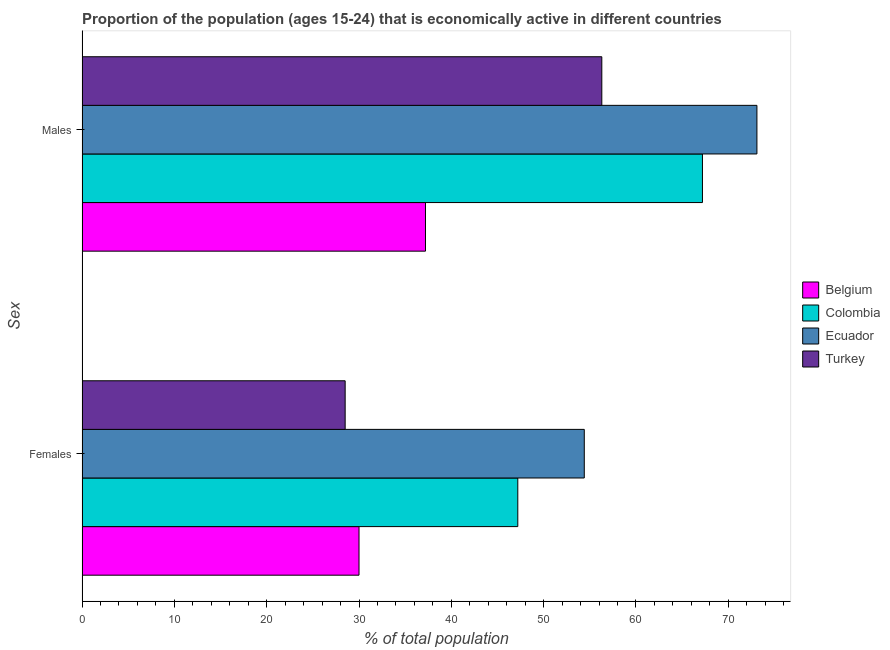How many different coloured bars are there?
Offer a very short reply. 4. How many groups of bars are there?
Provide a short and direct response. 2. Are the number of bars per tick equal to the number of legend labels?
Provide a succinct answer. Yes. Are the number of bars on each tick of the Y-axis equal?
Ensure brevity in your answer.  Yes. What is the label of the 1st group of bars from the top?
Give a very brief answer. Males. What is the percentage of economically active female population in Ecuador?
Your response must be concise. 54.4. Across all countries, what is the maximum percentage of economically active male population?
Your answer should be very brief. 73.1. Across all countries, what is the minimum percentage of economically active male population?
Ensure brevity in your answer.  37.2. In which country was the percentage of economically active male population maximum?
Your response must be concise. Ecuador. In which country was the percentage of economically active female population minimum?
Provide a succinct answer. Turkey. What is the total percentage of economically active female population in the graph?
Your answer should be very brief. 160.1. What is the difference between the percentage of economically active female population in Ecuador and that in Belgium?
Your answer should be very brief. 24.4. What is the difference between the percentage of economically active female population in Belgium and the percentage of economically active male population in Turkey?
Ensure brevity in your answer.  -26.3. What is the average percentage of economically active male population per country?
Ensure brevity in your answer.  58.45. What is the difference between the percentage of economically active female population and percentage of economically active male population in Colombia?
Provide a succinct answer. -20. What is the ratio of the percentage of economically active female population in Colombia to that in Belgium?
Make the answer very short. 1.57. In how many countries, is the percentage of economically active female population greater than the average percentage of economically active female population taken over all countries?
Provide a short and direct response. 2. What does the 2nd bar from the top in Females represents?
Offer a very short reply. Ecuador. Are all the bars in the graph horizontal?
Your answer should be very brief. Yes. Are the values on the major ticks of X-axis written in scientific E-notation?
Ensure brevity in your answer.  No. Does the graph contain any zero values?
Your response must be concise. No. How many legend labels are there?
Make the answer very short. 4. How are the legend labels stacked?
Provide a succinct answer. Vertical. What is the title of the graph?
Give a very brief answer. Proportion of the population (ages 15-24) that is economically active in different countries. What is the label or title of the X-axis?
Your answer should be compact. % of total population. What is the label or title of the Y-axis?
Keep it short and to the point. Sex. What is the % of total population in Belgium in Females?
Your answer should be very brief. 30. What is the % of total population of Colombia in Females?
Your answer should be very brief. 47.2. What is the % of total population of Ecuador in Females?
Your answer should be very brief. 54.4. What is the % of total population in Turkey in Females?
Your response must be concise. 28.5. What is the % of total population in Belgium in Males?
Offer a terse response. 37.2. What is the % of total population of Colombia in Males?
Give a very brief answer. 67.2. What is the % of total population of Ecuador in Males?
Your answer should be very brief. 73.1. What is the % of total population of Turkey in Males?
Provide a short and direct response. 56.3. Across all Sex, what is the maximum % of total population in Belgium?
Your answer should be very brief. 37.2. Across all Sex, what is the maximum % of total population of Colombia?
Your answer should be compact. 67.2. Across all Sex, what is the maximum % of total population of Ecuador?
Provide a short and direct response. 73.1. Across all Sex, what is the maximum % of total population of Turkey?
Offer a very short reply. 56.3. Across all Sex, what is the minimum % of total population in Colombia?
Give a very brief answer. 47.2. Across all Sex, what is the minimum % of total population of Ecuador?
Your answer should be compact. 54.4. What is the total % of total population of Belgium in the graph?
Offer a very short reply. 67.2. What is the total % of total population in Colombia in the graph?
Keep it short and to the point. 114.4. What is the total % of total population in Ecuador in the graph?
Offer a very short reply. 127.5. What is the total % of total population in Turkey in the graph?
Ensure brevity in your answer.  84.8. What is the difference between the % of total population of Ecuador in Females and that in Males?
Your response must be concise. -18.7. What is the difference between the % of total population of Turkey in Females and that in Males?
Make the answer very short. -27.8. What is the difference between the % of total population in Belgium in Females and the % of total population in Colombia in Males?
Give a very brief answer. -37.2. What is the difference between the % of total population of Belgium in Females and the % of total population of Ecuador in Males?
Keep it short and to the point. -43.1. What is the difference between the % of total population in Belgium in Females and the % of total population in Turkey in Males?
Provide a short and direct response. -26.3. What is the difference between the % of total population in Colombia in Females and the % of total population in Ecuador in Males?
Provide a succinct answer. -25.9. What is the difference between the % of total population in Colombia in Females and the % of total population in Turkey in Males?
Your answer should be compact. -9.1. What is the difference between the % of total population of Ecuador in Females and the % of total population of Turkey in Males?
Provide a short and direct response. -1.9. What is the average % of total population in Belgium per Sex?
Your response must be concise. 33.6. What is the average % of total population of Colombia per Sex?
Your answer should be compact. 57.2. What is the average % of total population of Ecuador per Sex?
Ensure brevity in your answer.  63.75. What is the average % of total population of Turkey per Sex?
Offer a very short reply. 42.4. What is the difference between the % of total population of Belgium and % of total population of Colombia in Females?
Offer a very short reply. -17.2. What is the difference between the % of total population of Belgium and % of total population of Ecuador in Females?
Your response must be concise. -24.4. What is the difference between the % of total population of Belgium and % of total population of Turkey in Females?
Provide a succinct answer. 1.5. What is the difference between the % of total population of Ecuador and % of total population of Turkey in Females?
Provide a short and direct response. 25.9. What is the difference between the % of total population in Belgium and % of total population in Colombia in Males?
Ensure brevity in your answer.  -30. What is the difference between the % of total population of Belgium and % of total population of Ecuador in Males?
Give a very brief answer. -35.9. What is the difference between the % of total population of Belgium and % of total population of Turkey in Males?
Make the answer very short. -19.1. What is the ratio of the % of total population of Belgium in Females to that in Males?
Offer a terse response. 0.81. What is the ratio of the % of total population of Colombia in Females to that in Males?
Your answer should be very brief. 0.7. What is the ratio of the % of total population of Ecuador in Females to that in Males?
Provide a succinct answer. 0.74. What is the ratio of the % of total population of Turkey in Females to that in Males?
Provide a succinct answer. 0.51. What is the difference between the highest and the second highest % of total population of Colombia?
Your answer should be very brief. 20. What is the difference between the highest and the second highest % of total population in Ecuador?
Your answer should be compact. 18.7. What is the difference between the highest and the second highest % of total population of Turkey?
Keep it short and to the point. 27.8. What is the difference between the highest and the lowest % of total population in Belgium?
Provide a succinct answer. 7.2. What is the difference between the highest and the lowest % of total population of Ecuador?
Offer a very short reply. 18.7. What is the difference between the highest and the lowest % of total population in Turkey?
Make the answer very short. 27.8. 